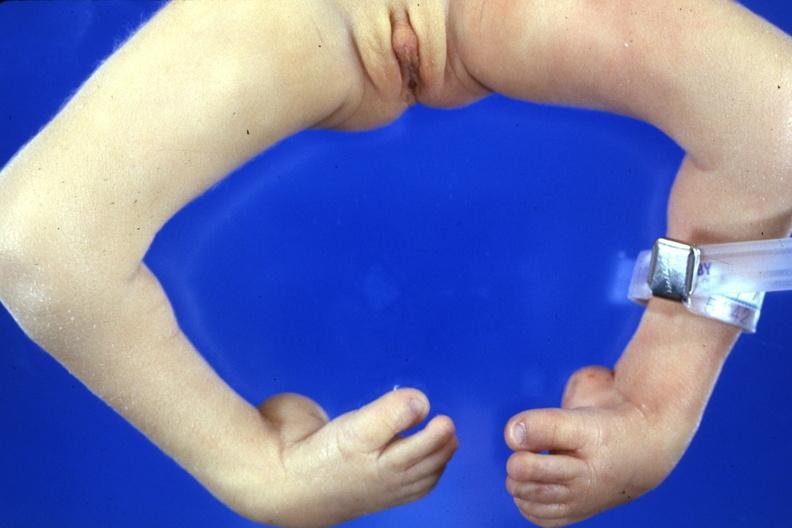what are present?
Answer the question using a single word or phrase. Extremities 